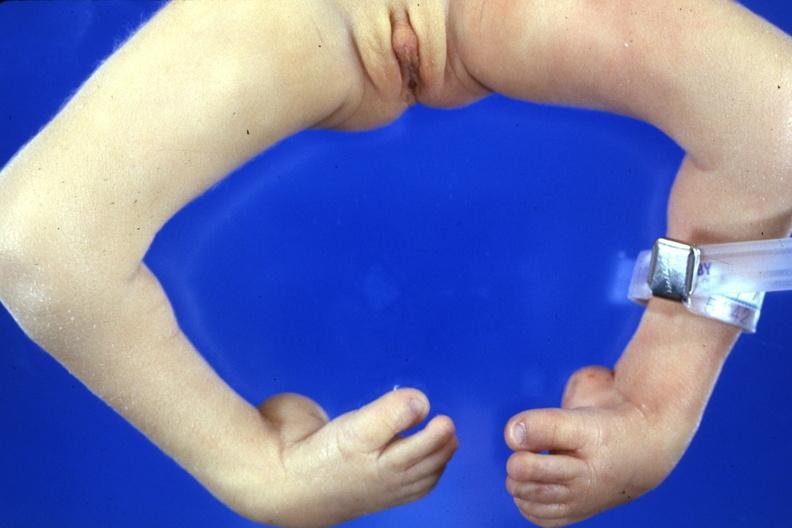what are present?
Answer the question using a single word or phrase. Extremities 